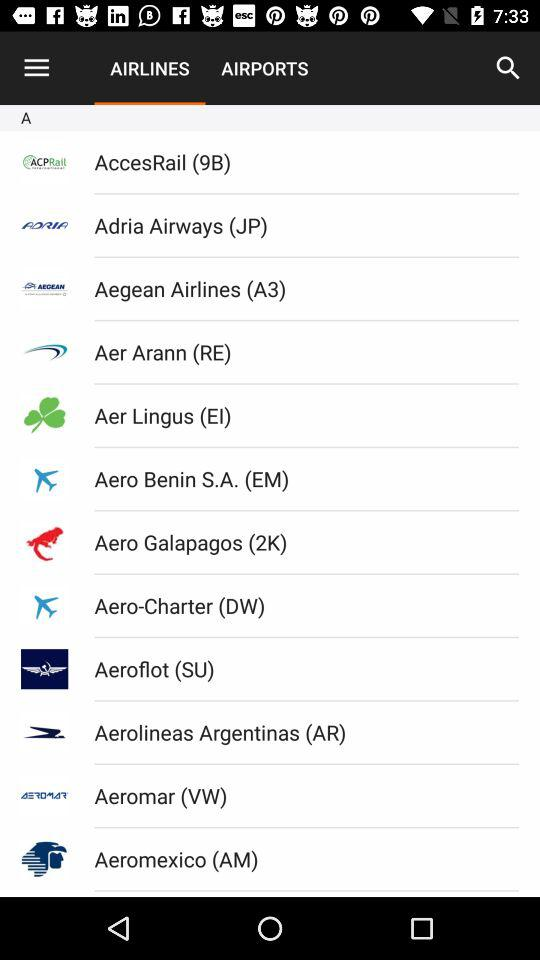Which tab am I on? You are on "AIRLINES" tab. 